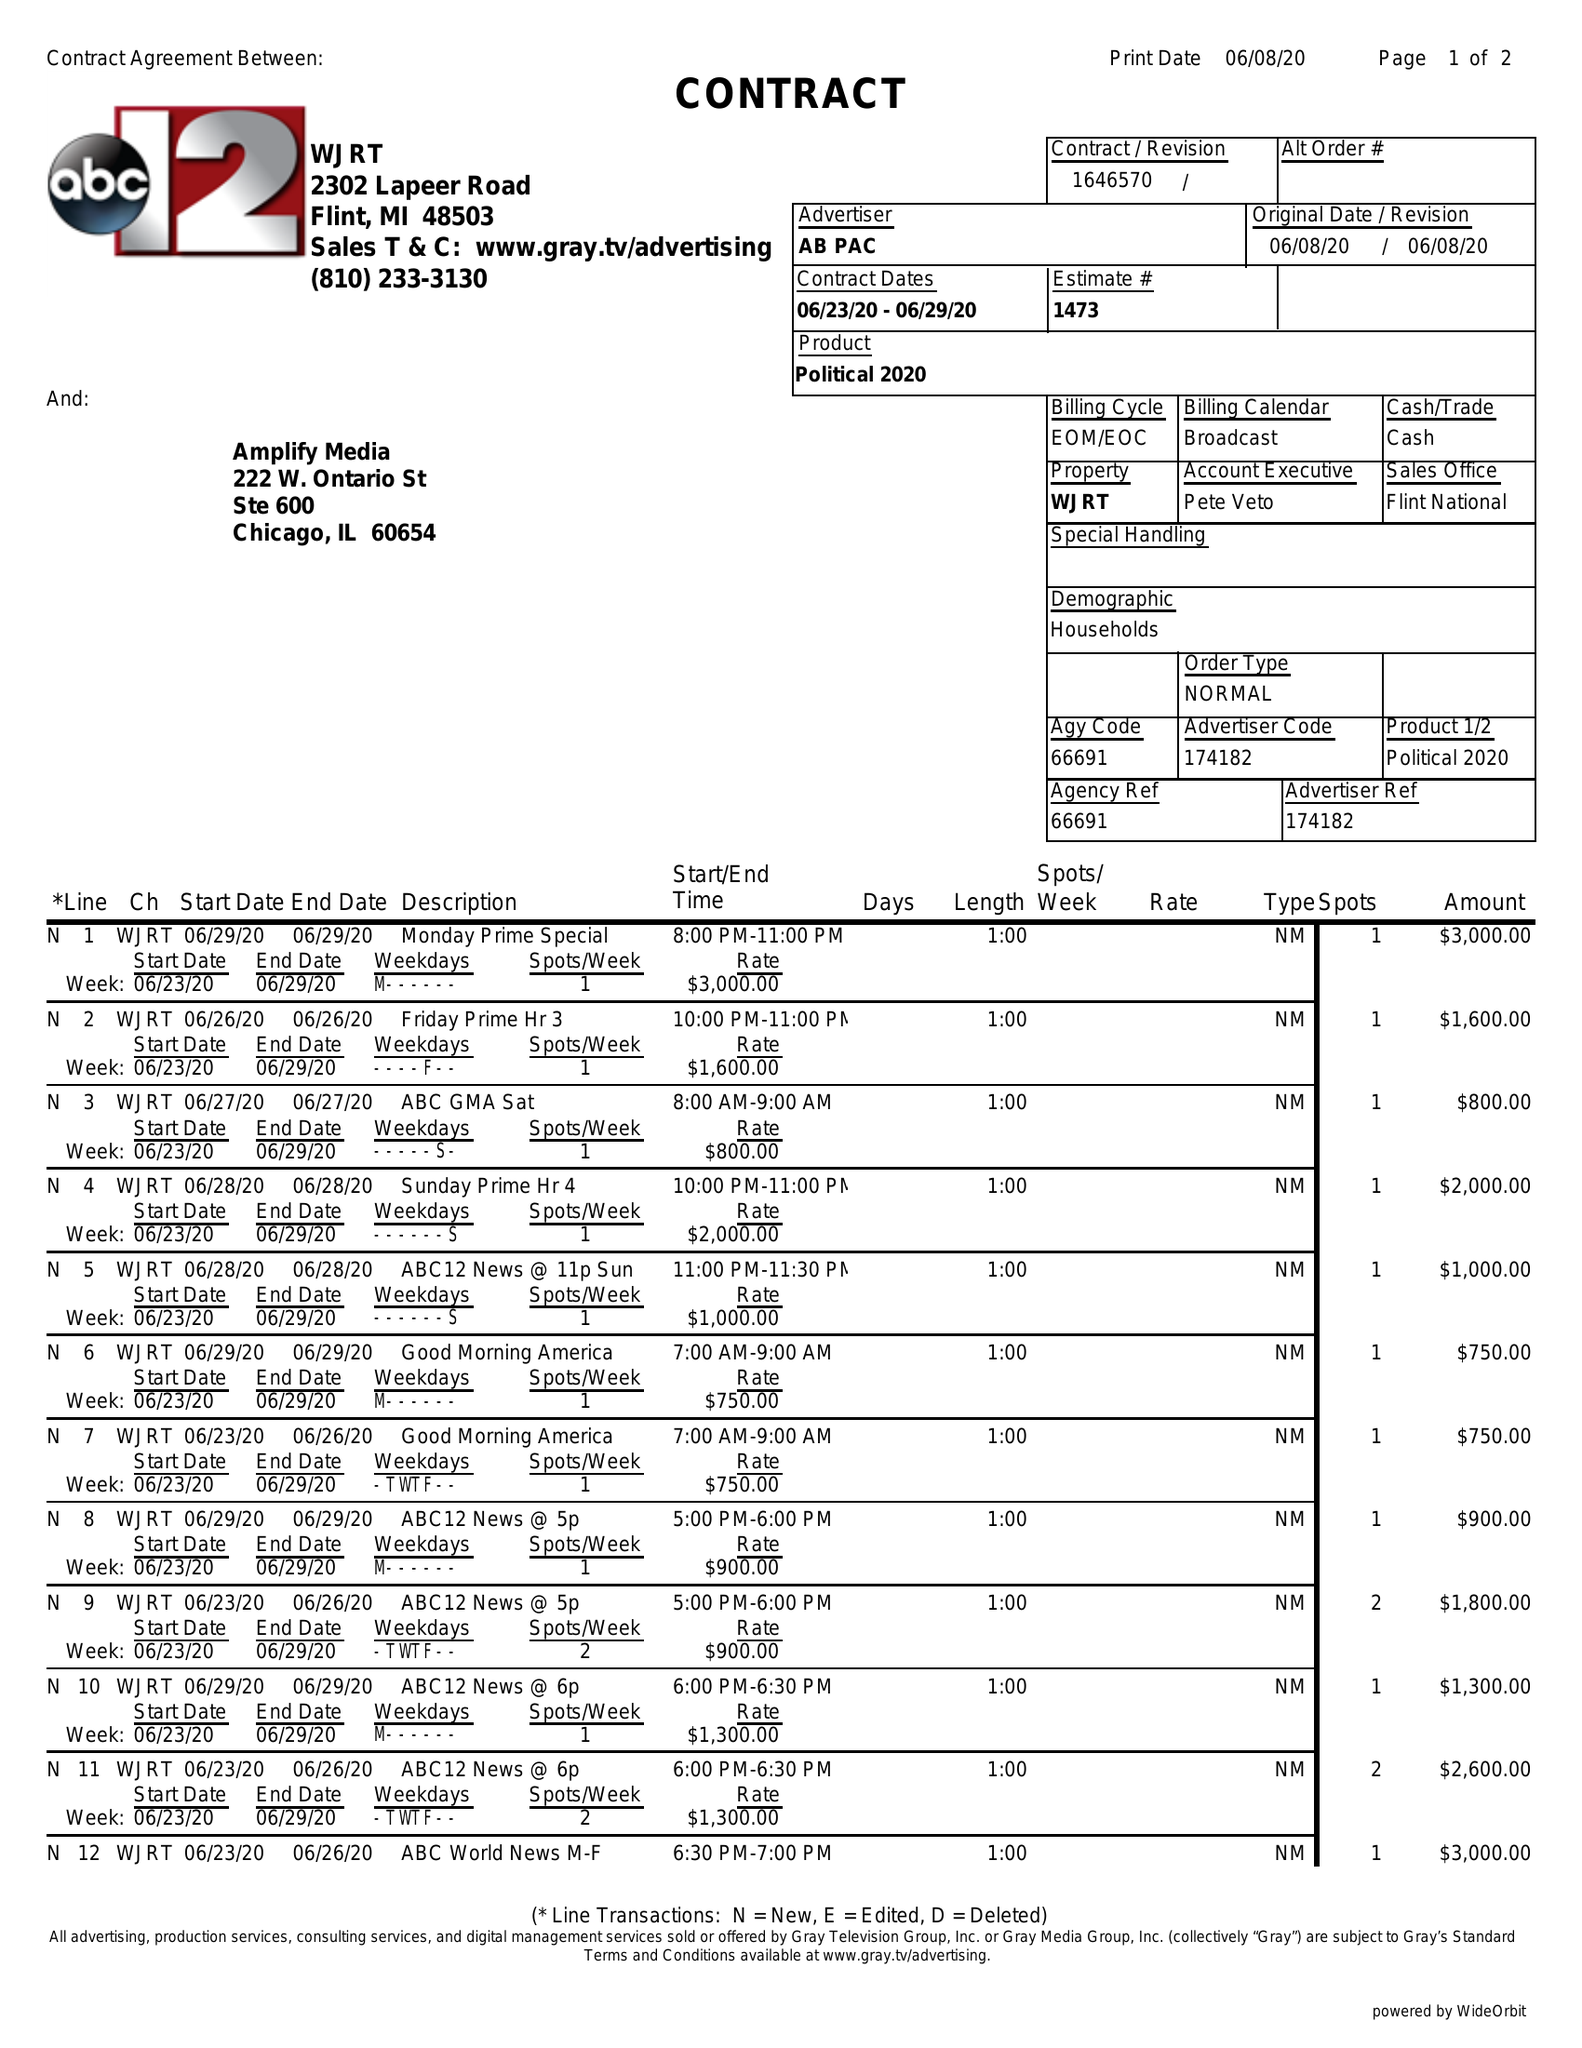What is the value for the contract_num?
Answer the question using a single word or phrase. 1646570 